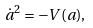<formula> <loc_0><loc_0><loc_500><loc_500>\dot { a } ^ { 2 } = - V ( a ) ,</formula> 